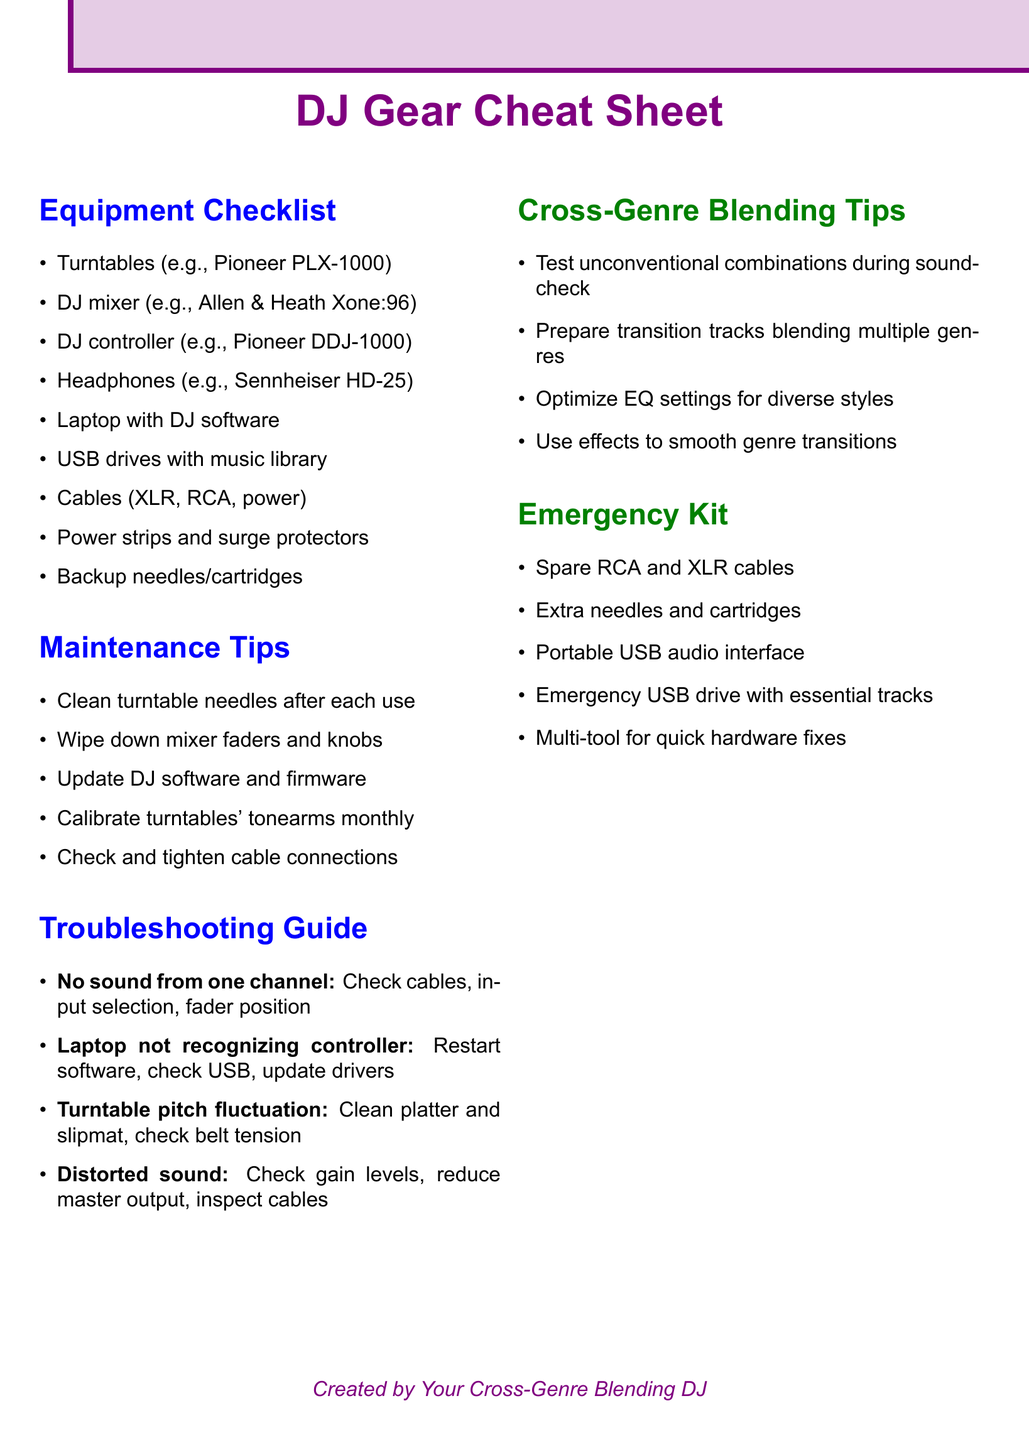What is the first item on the equipment checklist? The first item listed in the equipment checklist is the turntables.
Answer: Turntables (e.g., Pioneer PLX-1000) How many items are in the emergency kit? The emergency kit contains five specific items listed in the document.
Answer: 5 What is the recommended action for distorted sound? The document lists checking gain levels, reducing master output, and inspecting cables as solutions for distorted sound.
Answer: Check gain levels How often should turntables' tonearms be calibrated? The maintenance tips specify that tonearms should be calibrated monthly.
Answer: Monthly What color is used for the section headings in the document? The headings are styled using a specific shade of blue for visibility.
Answer: Blue What should be done if the laptop does not recognize the controller? The troubleshooting guide recommends restarting the software and checking the USB connection.
Answer: Restart software Which equipment is listed as a DJ controller? Among the items, the Pioneer DDJ-1000 is listed explicitly as a DJ controller.
Answer: Pioneer DDJ-1000 What is a consideration for cross-genre blending mentioned in the document? The document suggests preparing transition tracks that blend elements from multiple genres.
Answer: Prepare transition tracks What tool is included for quick hardware fixes in the emergency kit? A multi-tool is mentioned as a useful item for quick fixes in the emergency kit.
Answer: Multi-tool 